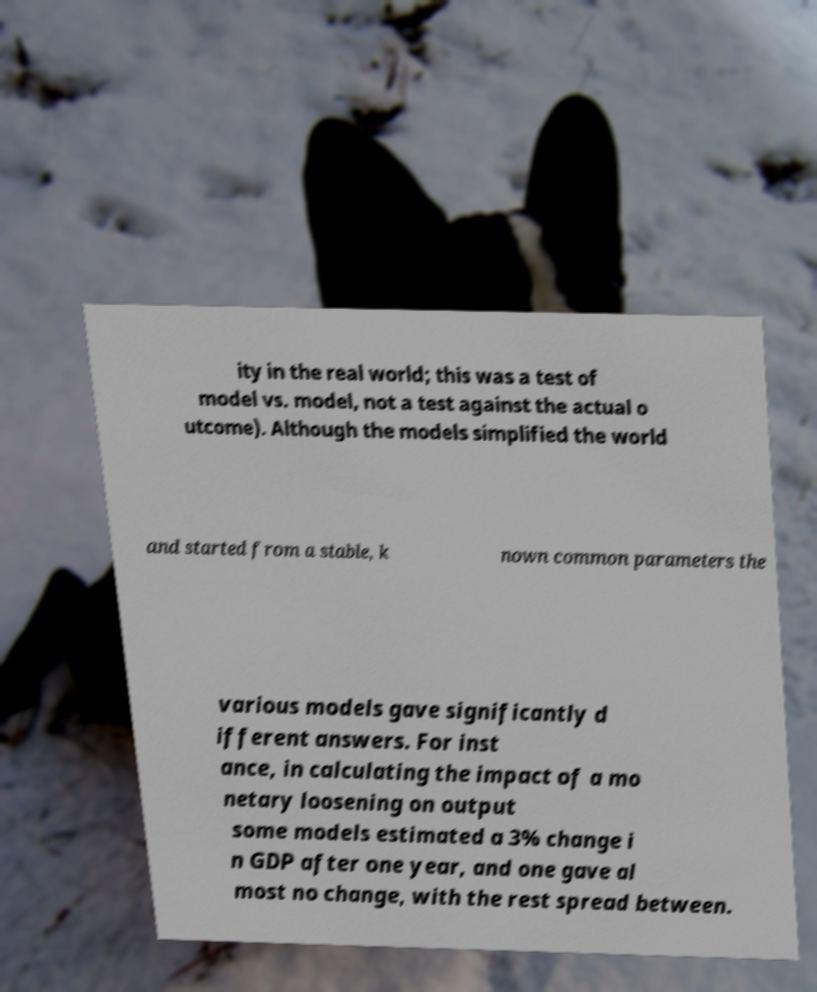Please identify and transcribe the text found in this image. ity in the real world; this was a test of model vs. model, not a test against the actual o utcome). Although the models simplified the world and started from a stable, k nown common parameters the various models gave significantly d ifferent answers. For inst ance, in calculating the impact of a mo netary loosening on output some models estimated a 3% change i n GDP after one year, and one gave al most no change, with the rest spread between. 